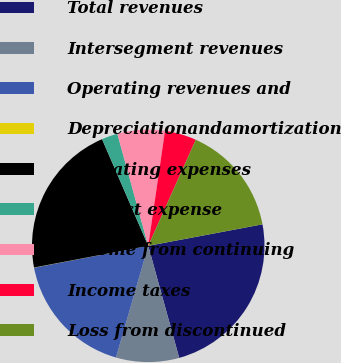Convert chart. <chart><loc_0><loc_0><loc_500><loc_500><pie_chart><fcel>Total revenues<fcel>Intersegment revenues<fcel>Operating revenues and<fcel>Depreciationandamortization<fcel>Operating expenses<fcel>Interest expense<fcel>Income from continuing<fcel>Income taxes<fcel>Loss from discontinued<nl><fcel>23.67%<fcel>8.77%<fcel>17.51%<fcel>0.03%<fcel>21.48%<fcel>2.22%<fcel>6.59%<fcel>4.4%<fcel>15.33%<nl></chart> 